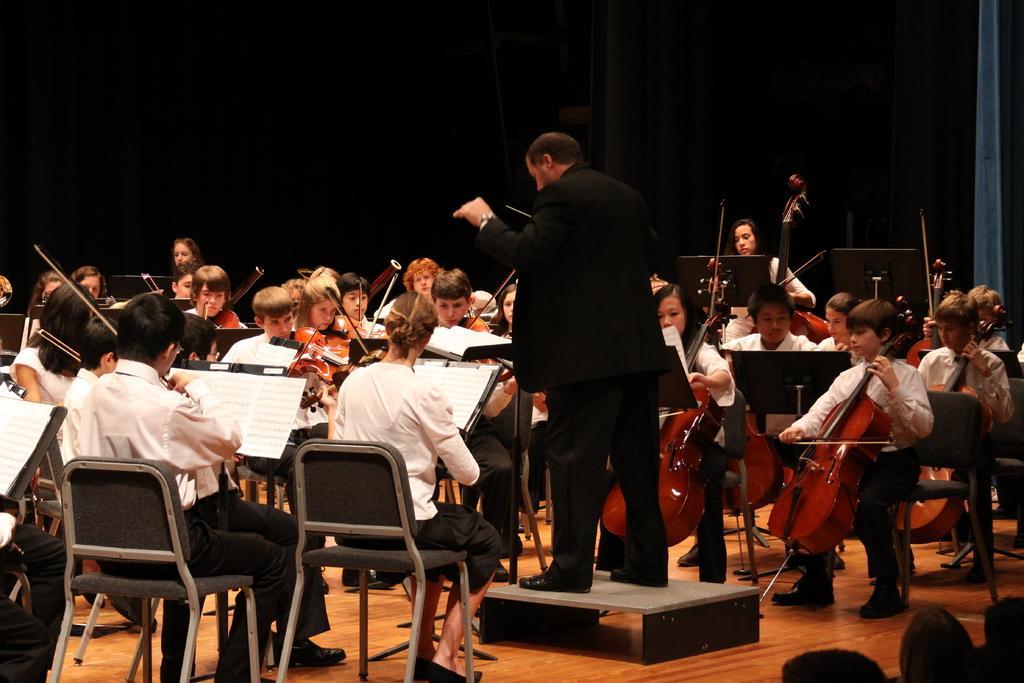Could you give a brief overview of what you see in this image? This is a picture taken in a room, there are group of kids sitting on chairs and playing music instruments. In front of the kids there are music books. The man in black blazer was standing on the floor and the man is holding a stick. Behind the people is in black color. This is a wooden floor. 